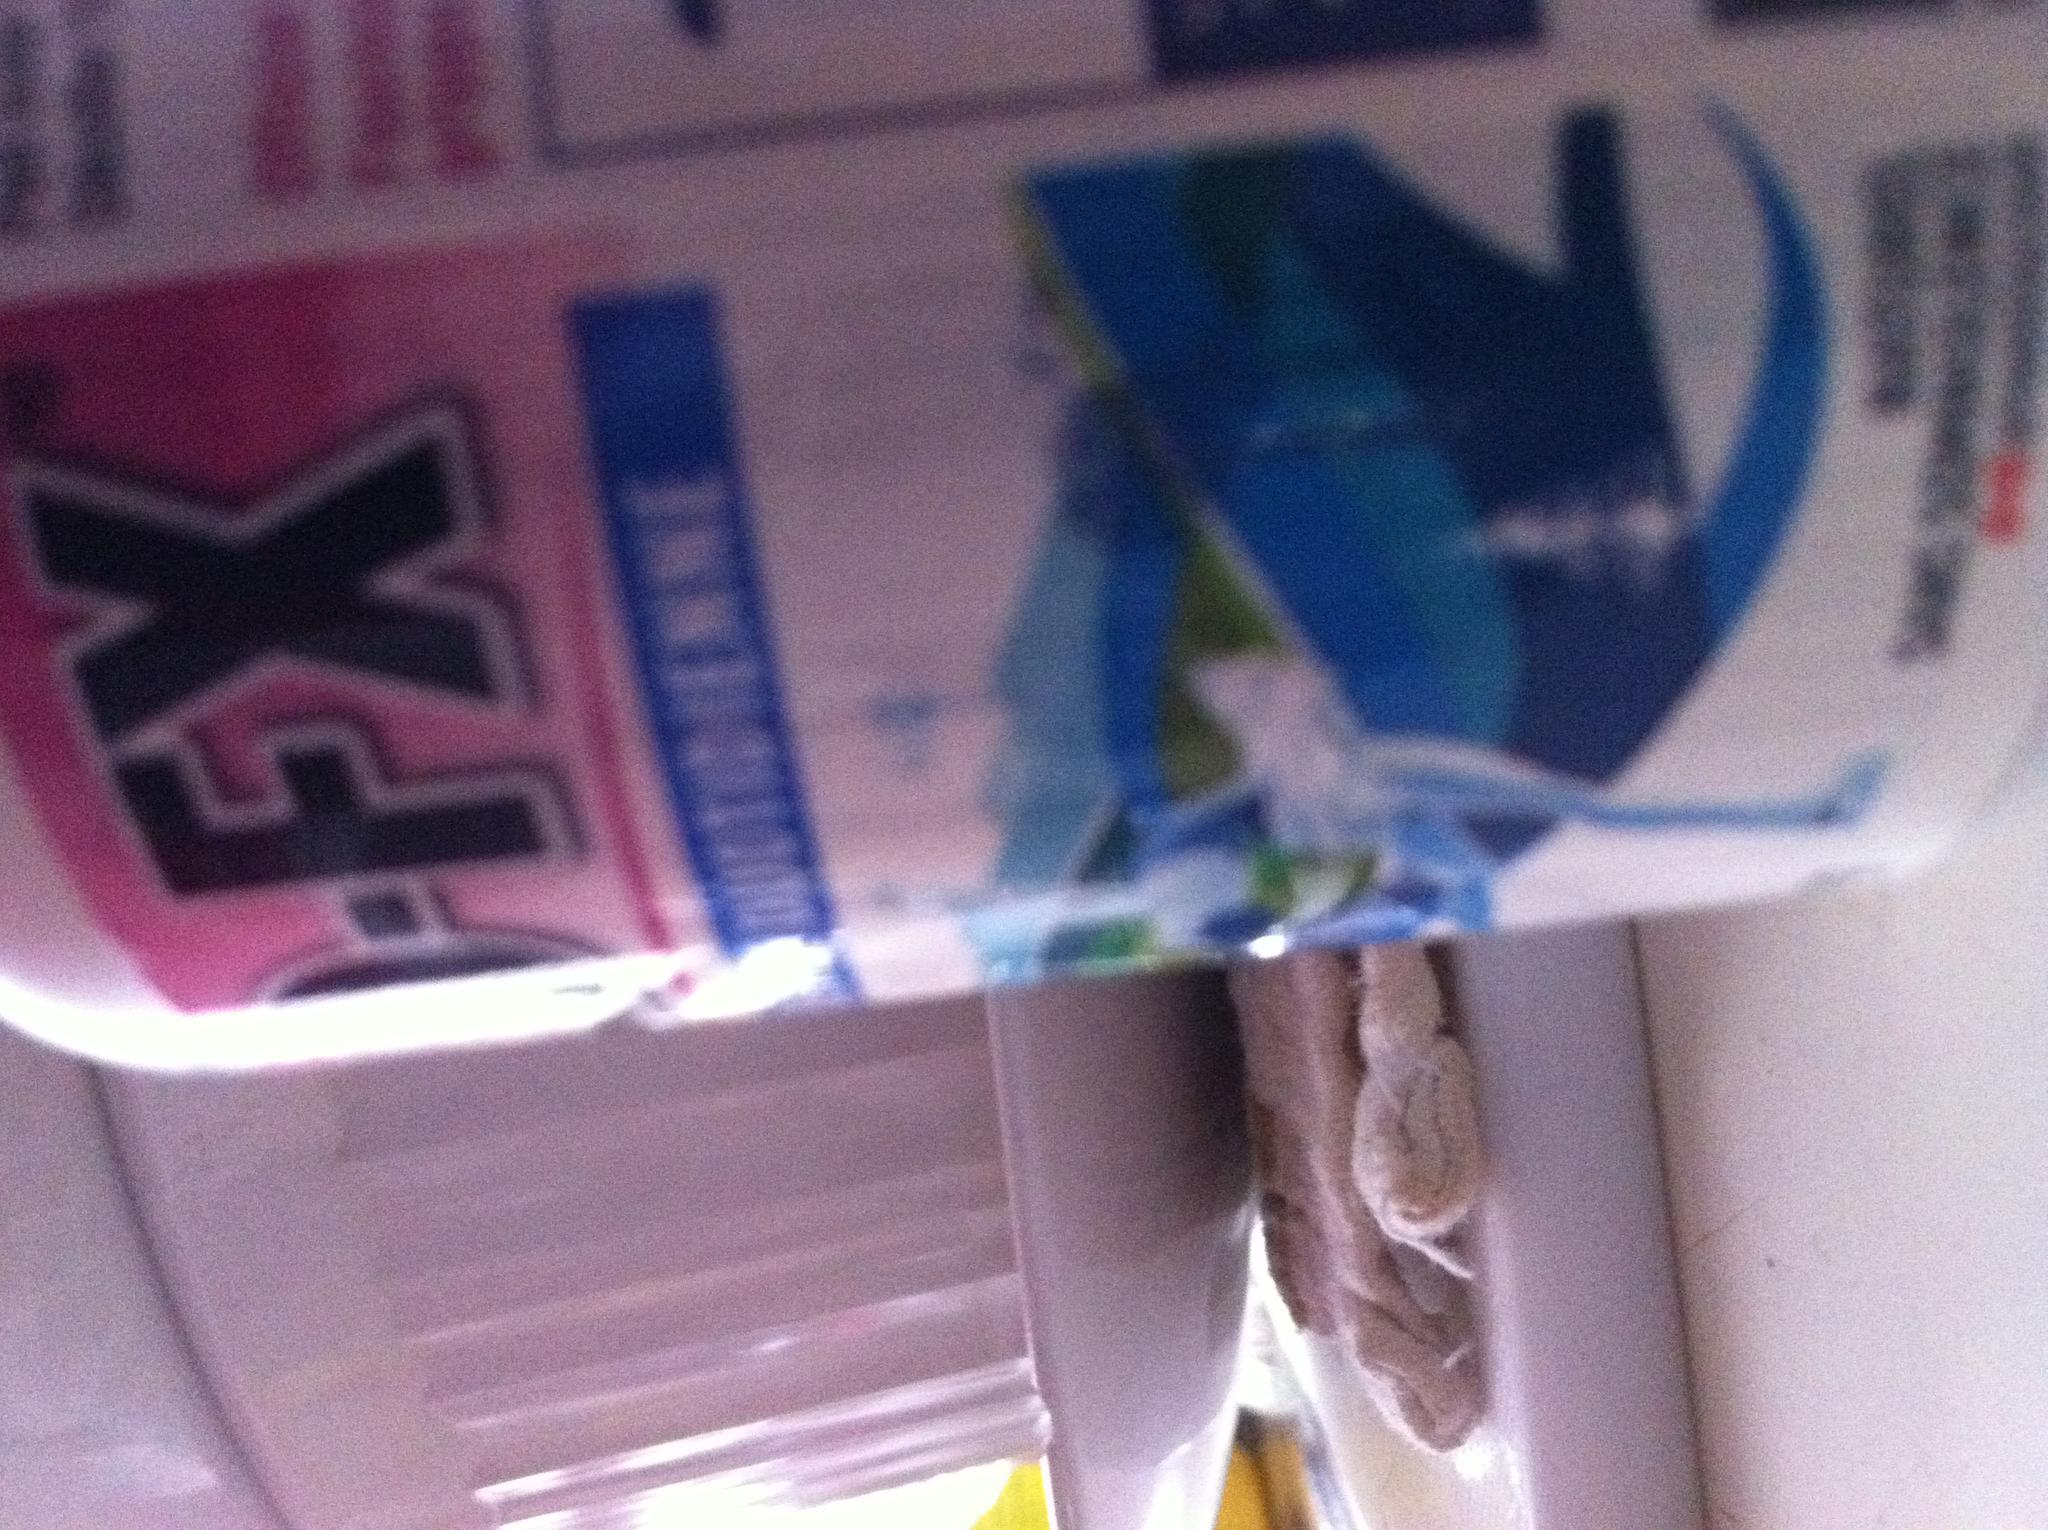What general safety tips should be followed when dealing with medications? When dealing with medications, it's essential to adhere to the following safety tips: always keep drugs in their original packaging until use, ensure the medication is stored out of reach of children, follow the prescribed dosages, and avoid sharing prescription medications with others. Additionally, always check expiration dates, and dispose of expired or unused medications safely. 